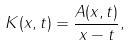Convert formula to latex. <formula><loc_0><loc_0><loc_500><loc_500>K ( x , t ) = \frac { A ( x , t ) } { x - t } ,</formula> 